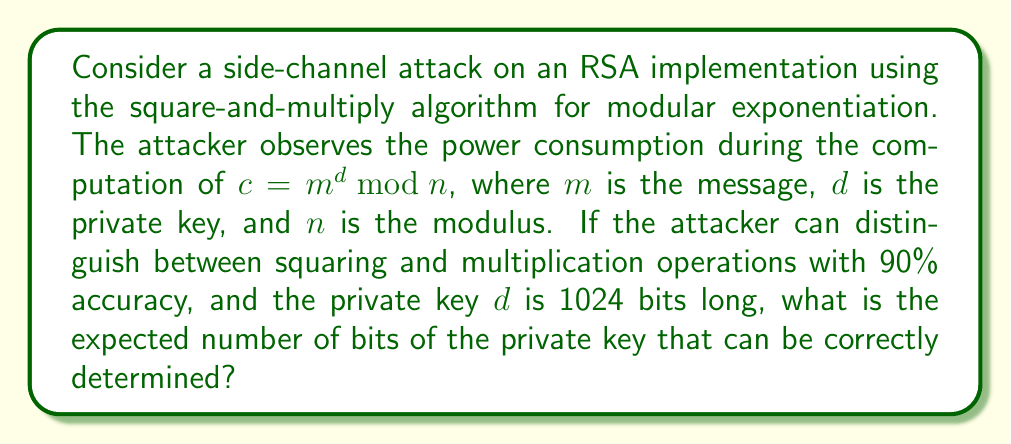Provide a solution to this math problem. Let's approach this step-by-step:

1) In the square-and-multiply algorithm, each bit of the private key $d$ corresponds to one iteration of the main loop.

2) For each bit:
   - A squaring operation is always performed.
   - A multiplication is performed only if the bit is 1.

3) The attacker can distinguish between these operations with 90% accuracy. This means:
   - For 90% of the bits, the attacker will correctly identify whether a multiplication occurred (indicating a 1) or not (indicating a 0).
   - For 10% of the bits, the attacker will make an incorrect identification.

4) The expected number of correctly identified bits can be calculated as:

   $$E(\text{correct bits}) = 1024 \times 0.90 = 921.6$$

5) Since we're dealing with bits, we need to round this to the nearest whole number:

   $$E(\text{correct bits}) \approx 922$$

Therefore, out of the 1024 bits of the private key, the attacker can be expected to correctly determine approximately 922 bits.
Answer: 922 bits 